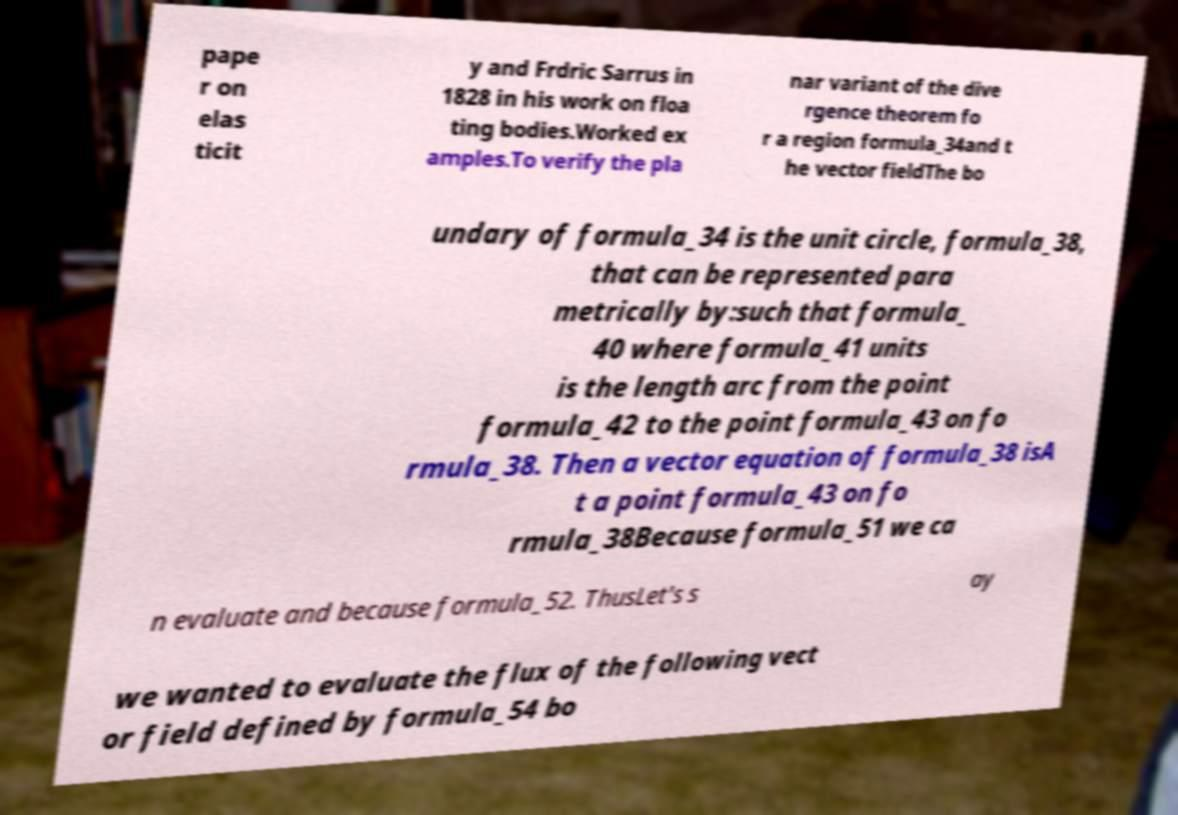For documentation purposes, I need the text within this image transcribed. Could you provide that? pape r on elas ticit y and Frdric Sarrus in 1828 in his work on floa ting bodies.Worked ex amples.To verify the pla nar variant of the dive rgence theorem fo r a region formula_34and t he vector fieldThe bo undary of formula_34 is the unit circle, formula_38, that can be represented para metrically by:such that formula_ 40 where formula_41 units is the length arc from the point formula_42 to the point formula_43 on fo rmula_38. Then a vector equation of formula_38 isA t a point formula_43 on fo rmula_38Because formula_51 we ca n evaluate and because formula_52. ThusLet's s ay we wanted to evaluate the flux of the following vect or field defined by formula_54 bo 